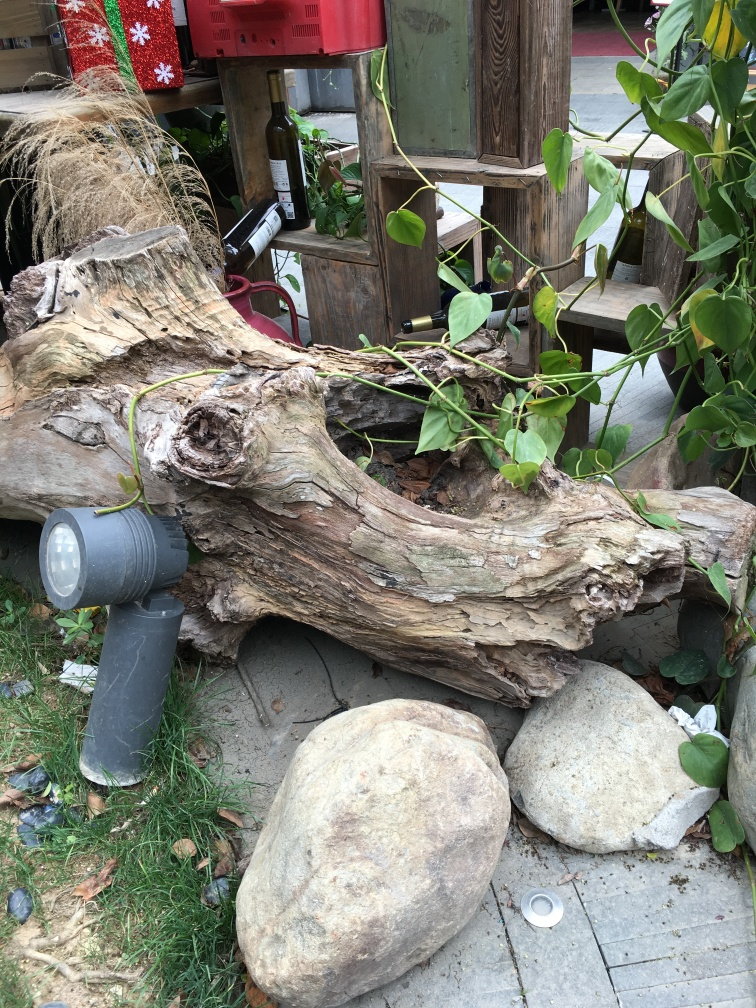Can you tell the time of year this photo might have been taken? The presence of green leaves suggests it could be spring or summer, yet the earth tones and slightly dried plants hint at a transition from summer to autumn. Without seasonal indicators like flowers or snow, it's challenging to pinpoint the exact time of year. Do you notice any elements that need attention in this scene? Yes, for maintenance purposes, the area could benefit from a bit of tidying. There are fallen leaves and a small piece of litter visible on the ground, which could be cleared to enhance the space's overall aesthetic appeal. 